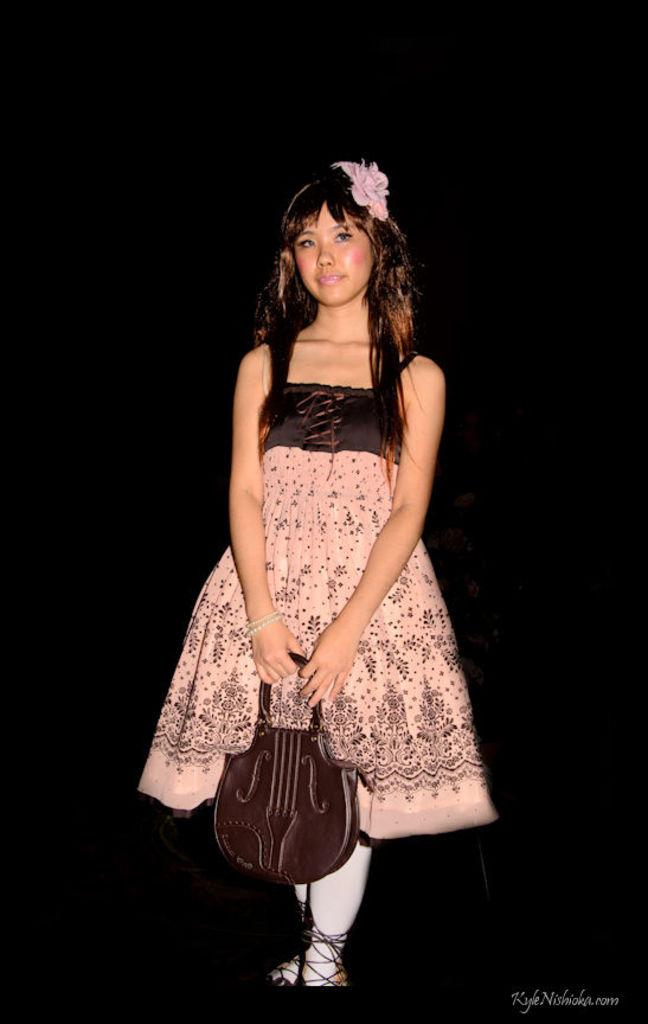Who is the main subject in the image? There is a woman in the image. What is the woman wearing? The woman is wearing a pink frock. What object is the woman holding in the image? The woman is holding a bag shaped like a guitar. What type of parent is depicted in the image? There is no parent depicted in the image; it features a woman holding a bag shaped like a guitar. Can you tell me how many scales are visible in the image? There are no scales present in the image. 